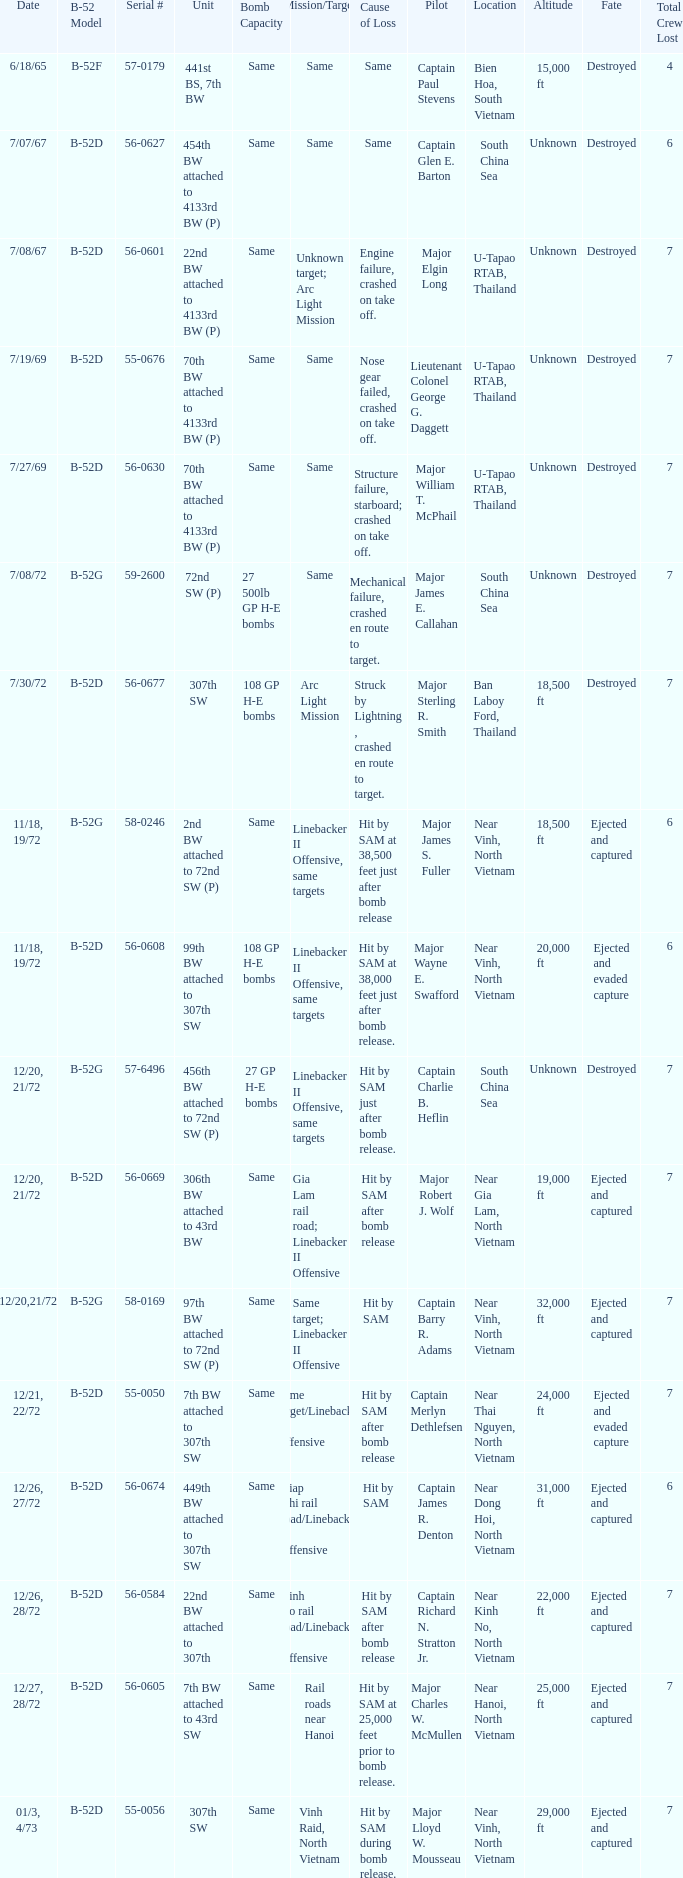When 441st bs, 7th bw is the unit what is the b-52 model? B-52F. 